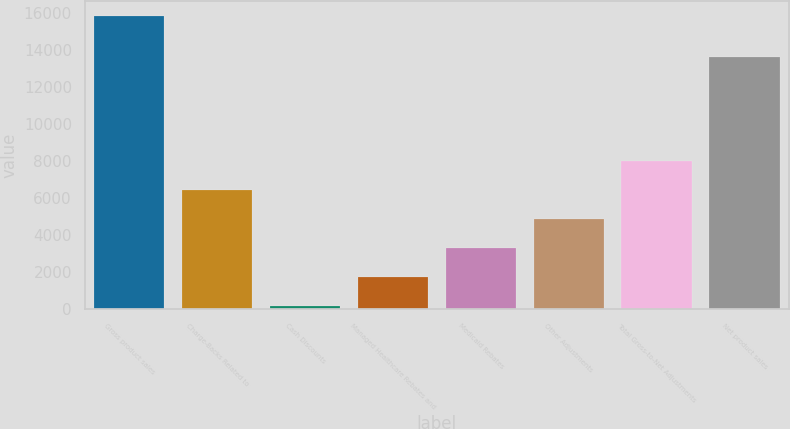Convert chart to OTSL. <chart><loc_0><loc_0><loc_500><loc_500><bar_chart><fcel>Gross product sales<fcel>Charge-Backs Related to<fcel>Cash Discounts<fcel>Managed Healthcare Rebates and<fcel>Medicaid Rebates<fcel>Other Adjustments<fcel>Total Gross-to-Net Adjustments<fcel>Net product sales<nl><fcel>15849<fcel>6454.8<fcel>192<fcel>1757.7<fcel>3323.4<fcel>4889.1<fcel>8020.5<fcel>13654<nl></chart> 